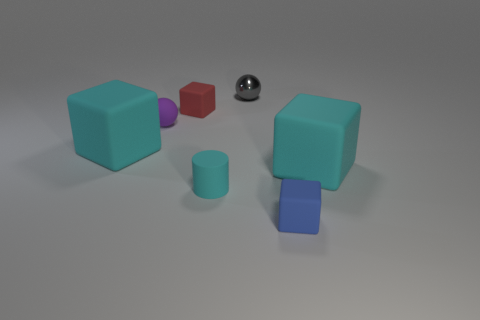Add 2 tiny purple metal blocks. How many objects exist? 9 Subtract all blue blocks. How many blocks are left? 3 Subtract all red cubes. How many cubes are left? 3 Add 4 gray metal things. How many gray metal things are left? 5 Add 7 big cyan matte cubes. How many big cyan matte cubes exist? 9 Subtract 1 cyan cylinders. How many objects are left? 6 Subtract all cylinders. How many objects are left? 6 Subtract 2 spheres. How many spheres are left? 0 Subtract all blue blocks. Subtract all purple cylinders. How many blocks are left? 3 Subtract all gray spheres. How many blue blocks are left? 1 